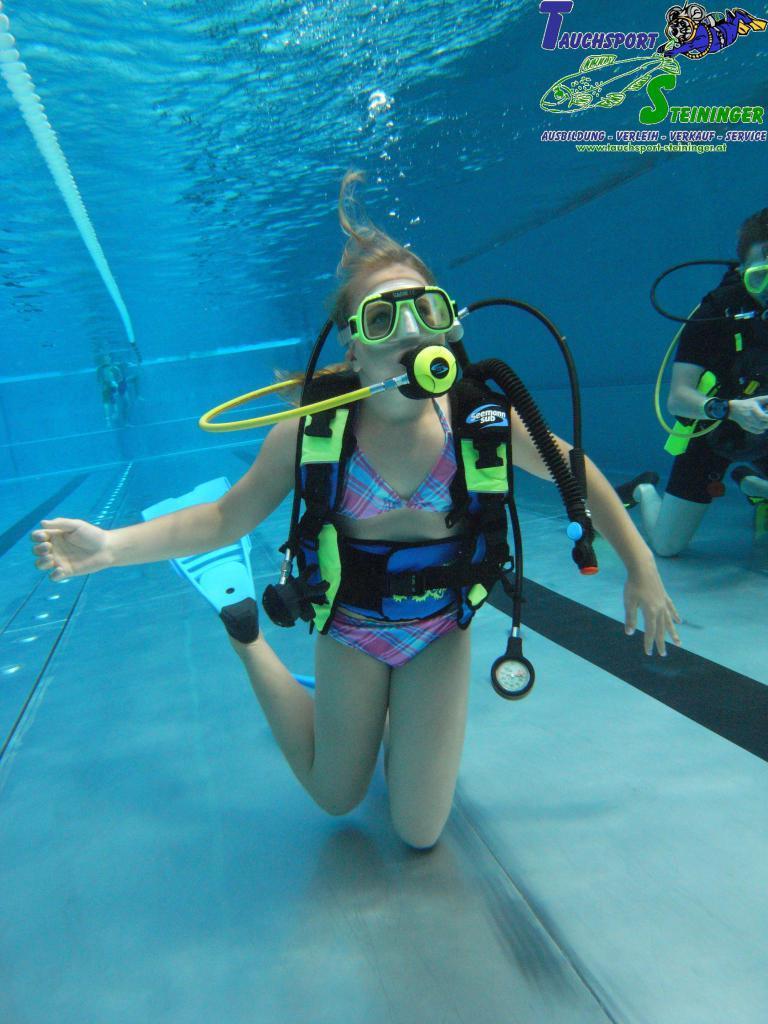In one or two sentences, can you explain what this image depicts? In this picture there is a girl in the center of the image, she is swimming in the water and there is another person on the right side of the image, there is water around the area of the image. 